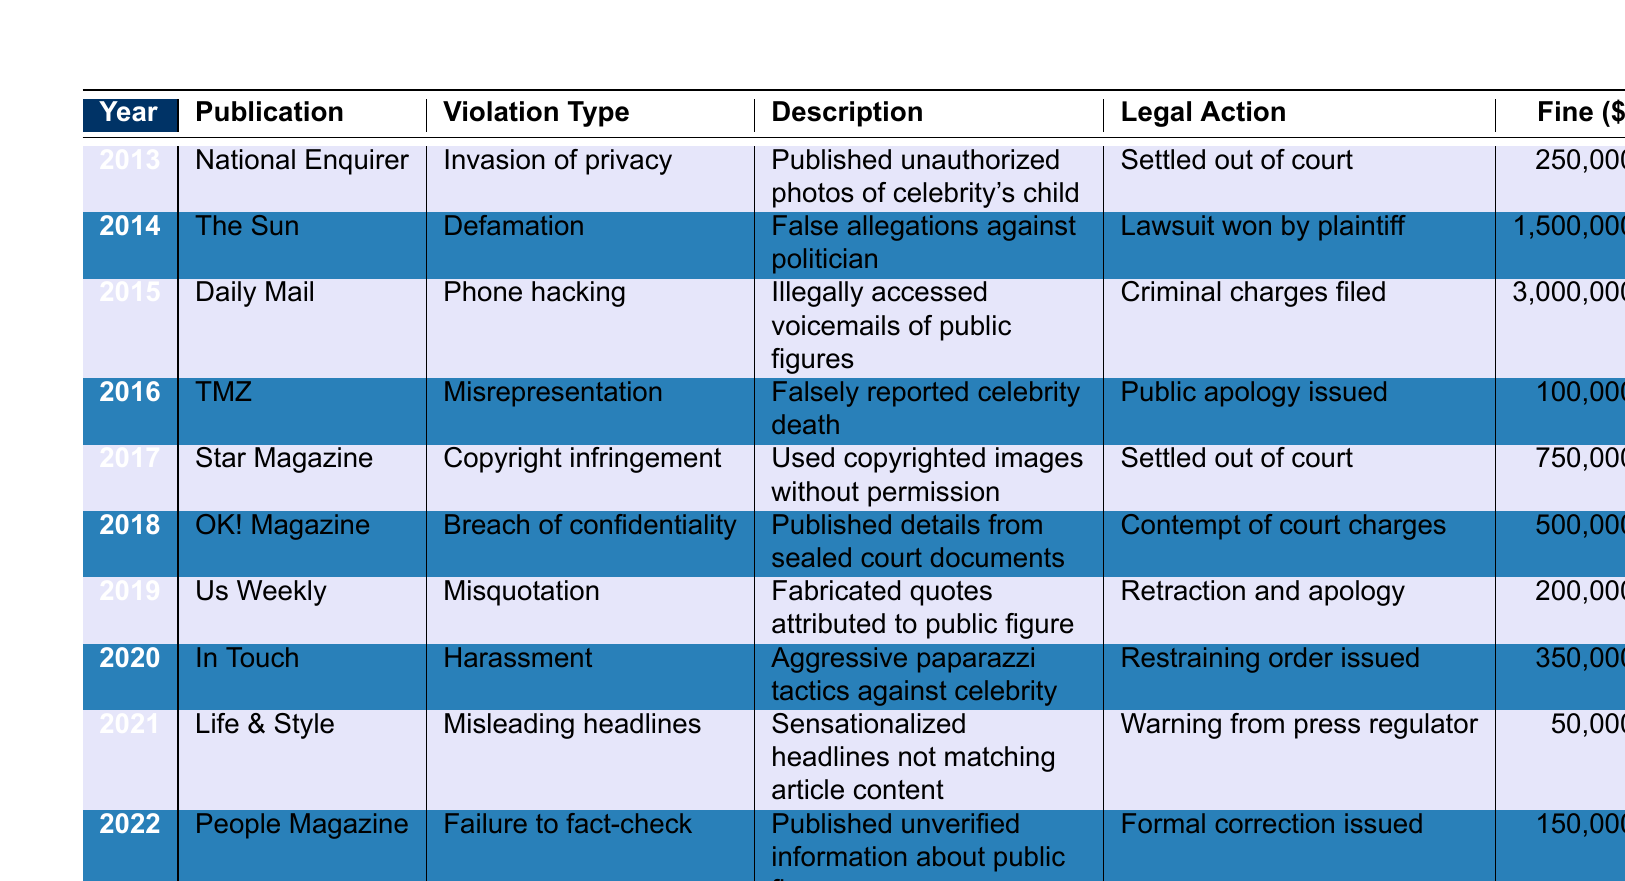What was the violation type reported for the National Enquirer in 2013? In the table, look for the row corresponding to the year 2013 and the publication National Enquirer. The violation type in that row is listed as "Invasion of privacy."
Answer: Invasion of privacy Which publication faced a lawsuit and won in 2014? In the 2014 row, the publication listed is "The Sun," and the legal action states that a "Lawsuit won by plaintiff." Therefore, The Sun faced and won a lawsuit.
Answer: The Sun What is the total fine amount for violations reported in 2015 and 2016? To find the total, add the fine amounts from the years 2015 and 2016: 3,000,000 (2015) + 100,000 (2016) = 3,100,000.
Answer: 3,100,000 Did OK! Magazine violate any ethical guidelines in 2018? Yes, according to the table, OK! Magazine's violation in 2018 is classified as "Breach of confidentiality."
Answer: Yes Which publication had the highest fine amount recorded in the table? Review each fine amount in the table, and the highest fine of 3,000,000 corresponds to the Daily Mail in 2015 for phone hacking.
Answer: Daily Mail What was the legal action taken against Life & Style in 2021? The table indicates that for Life & Style in 2021, the legal action recorded was a "Warning from press regulator."
Answer: Warning from press regulator How many different violation types are reported in the table? Count each unique violation type listed in the table: Invasion of privacy, Defamation, Phone hacking, Misrepresentation, Copyright infringement, Breach of confidentiality, Misquotation, Harassment, Misleading headlines, and Failure to fact-check. There are ten unique types.
Answer: 10 Were fines issued for all the violations listed in the table? No, not all listed violations resulted in fines. For instance, the legal action for TMZ in 2016 was a public apology, which typically does not involve a fine.
Answer: No Which year saw the most significant legal consequence in terms of fines? Analyzing the fines, 2015 stands out with a fine amount of 3,000,000 for phone hacking associated with Daily Mail, indicating it had the most significant consequence that year.
Answer: 2015 What percentage of the total fines in the table is attributed to the Daily Mail? First, sum the total fines from all entries: 250,000 + 1,500,000 + 3,000,000 + 100,000 + 750,000 + 500,000 + 200,000 + 350,000 + 50,000 + 150,000 = 6,100,000. Then divide the Daily Mail's fine of 3,000,000 by this total and multiply by 100: (3,000,000 / 6,100,000) * 100 = approximately 49.18%.
Answer: 49.18% 